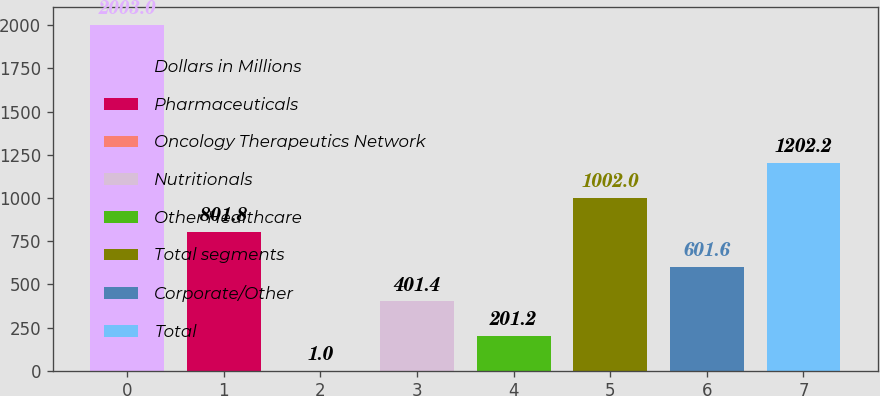<chart> <loc_0><loc_0><loc_500><loc_500><bar_chart><fcel>Dollars in Millions<fcel>Pharmaceuticals<fcel>Oncology Therapeutics Network<fcel>Nutritionals<fcel>Other Healthcare<fcel>Total segments<fcel>Corporate/Other<fcel>Total<nl><fcel>2003<fcel>801.8<fcel>1<fcel>401.4<fcel>201.2<fcel>1002<fcel>601.6<fcel>1202.2<nl></chart> 